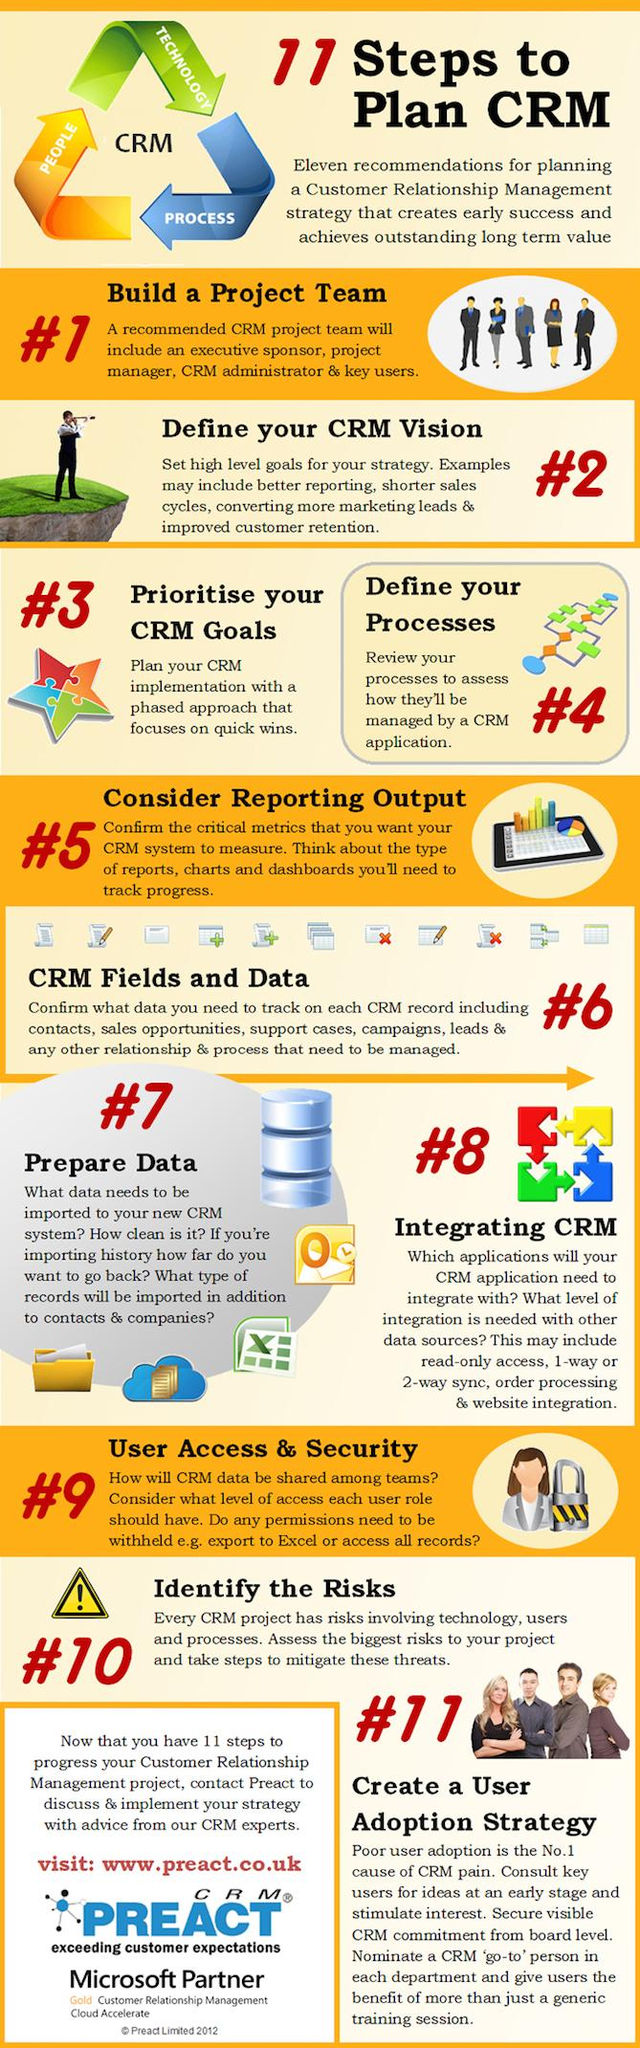Identify some key points in this picture. Customer Relationship Management connects people, technology, and processes to enhance the overall customer experience. The step that comes before step 8 in the CRM recommendations is "Prepare Data. After completing step 3 in the CRM recommendations, the next step is to define the processes involved in the organization's operations. 